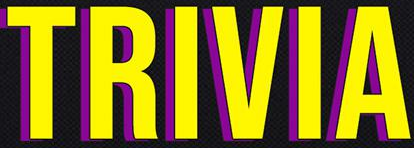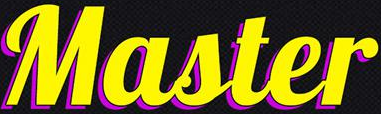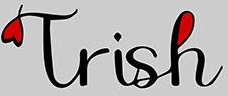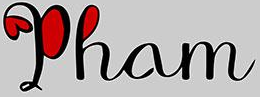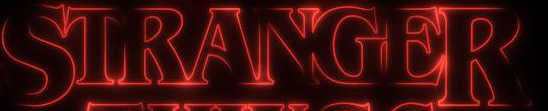Identify the words shown in these images in order, separated by a semicolon. TRIVIA; Master; Trish; Pham; STRANGER 